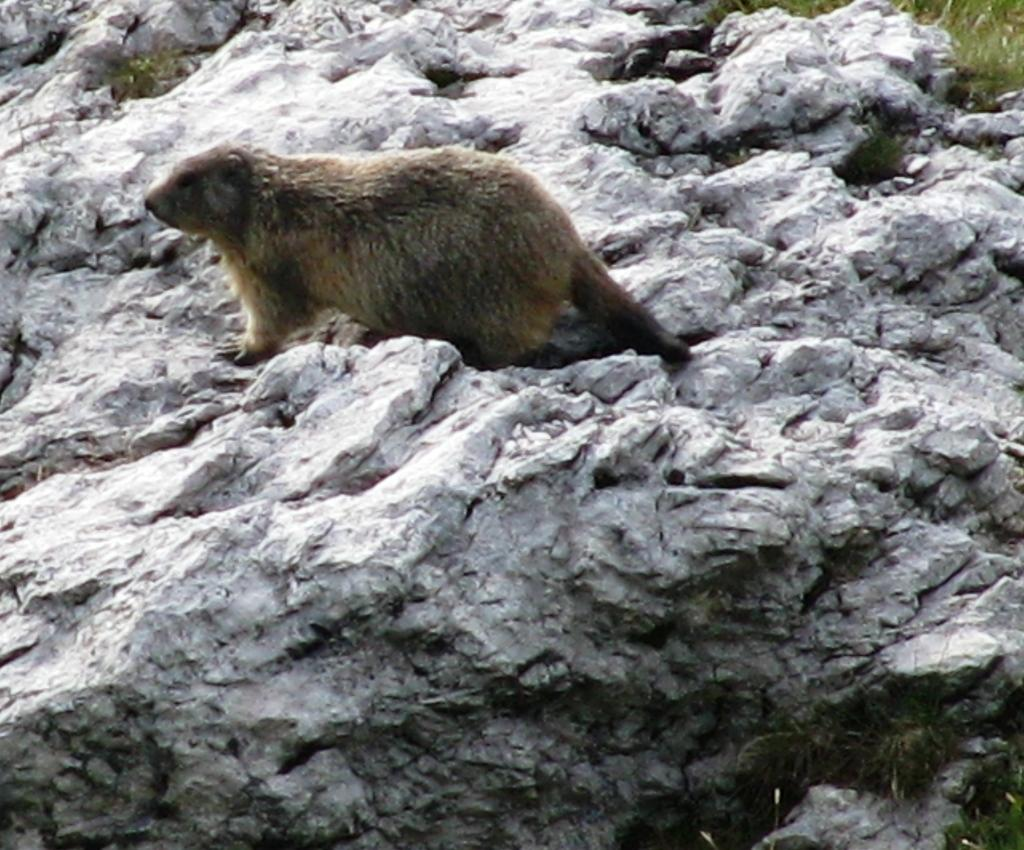What is the main subject of the image? There is an animal on a rock in the image. Can you describe the environment in the image? There is grass visible on the right side top of the image. What type of substance is the kitty carrying in the basket in the image? There is no kitty or basket present in the image. 